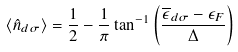<formula> <loc_0><loc_0><loc_500><loc_500>\langle \hat { n } _ { d \sigma } \rangle = \frac { 1 } { 2 } - \frac { 1 } { \pi } \tan ^ { - 1 } \left ( \frac { \overline { \epsilon } _ { d \sigma } - \epsilon _ { F } } \Delta \right )</formula> 